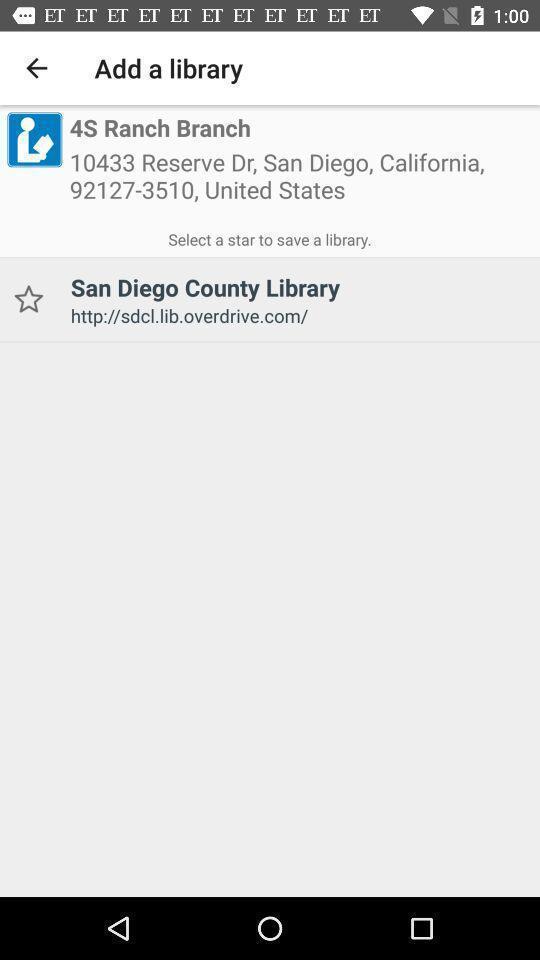Describe the visual elements of this screenshot. Screen displaying the page to add a library. 